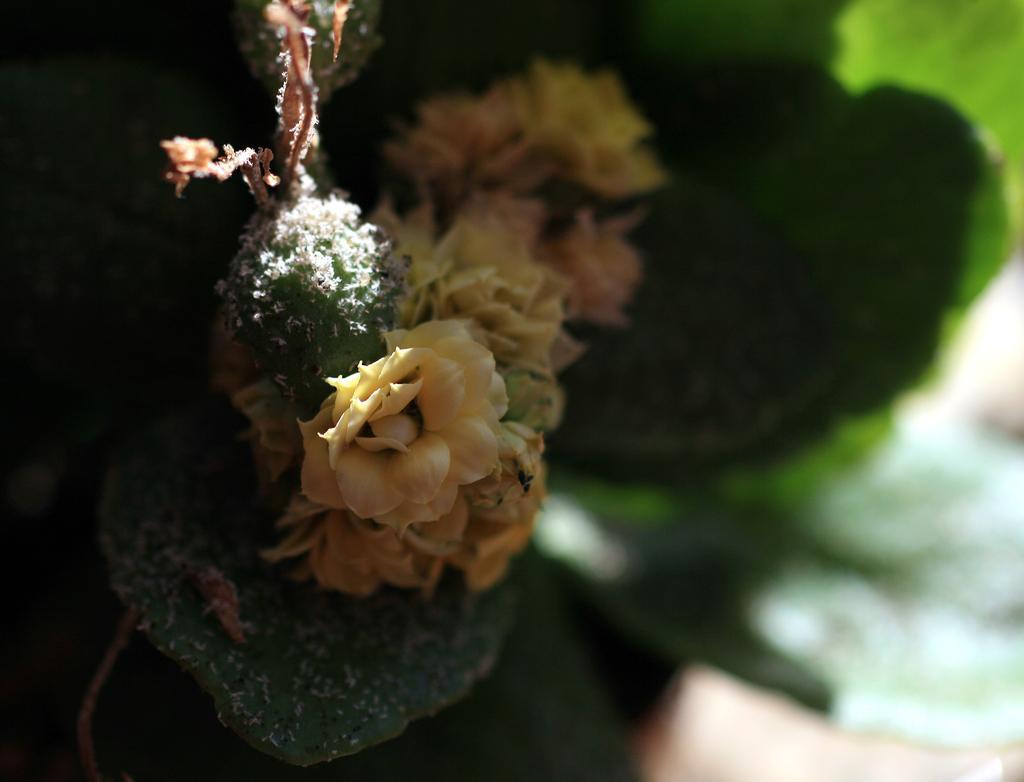How would you summarize this image in a sentence or two? In the image there is a plant with flowers. There is a blur image on the right side. 